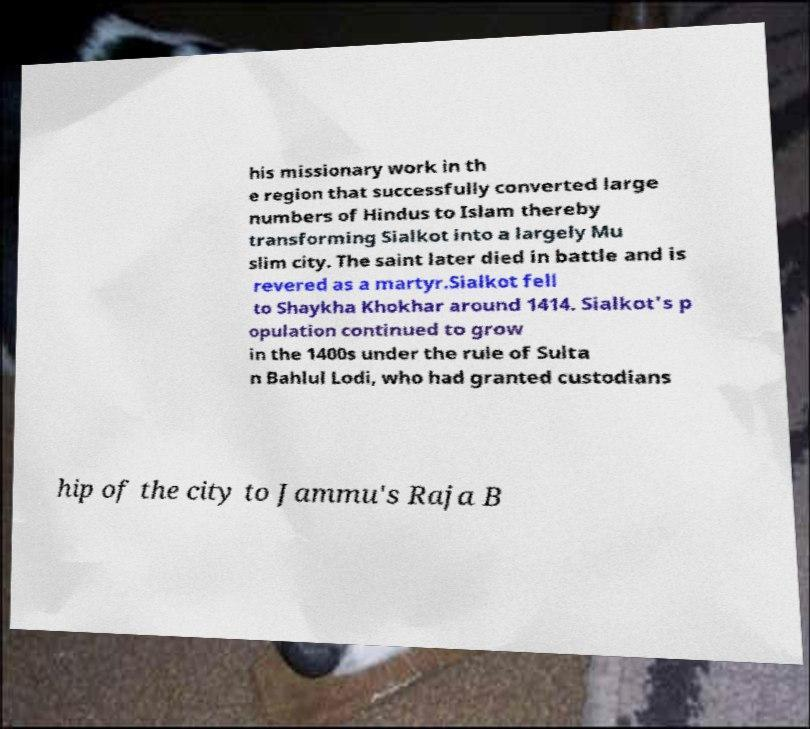I need the written content from this picture converted into text. Can you do that? his missionary work in th e region that successfully converted large numbers of Hindus to Islam thereby transforming Sialkot into a largely Mu slim city. The saint later died in battle and is revered as a martyr.Sialkot fell to Shaykha Khokhar around 1414. Sialkot's p opulation continued to grow in the 1400s under the rule of Sulta n Bahlul Lodi, who had granted custodians hip of the city to Jammu's Raja B 